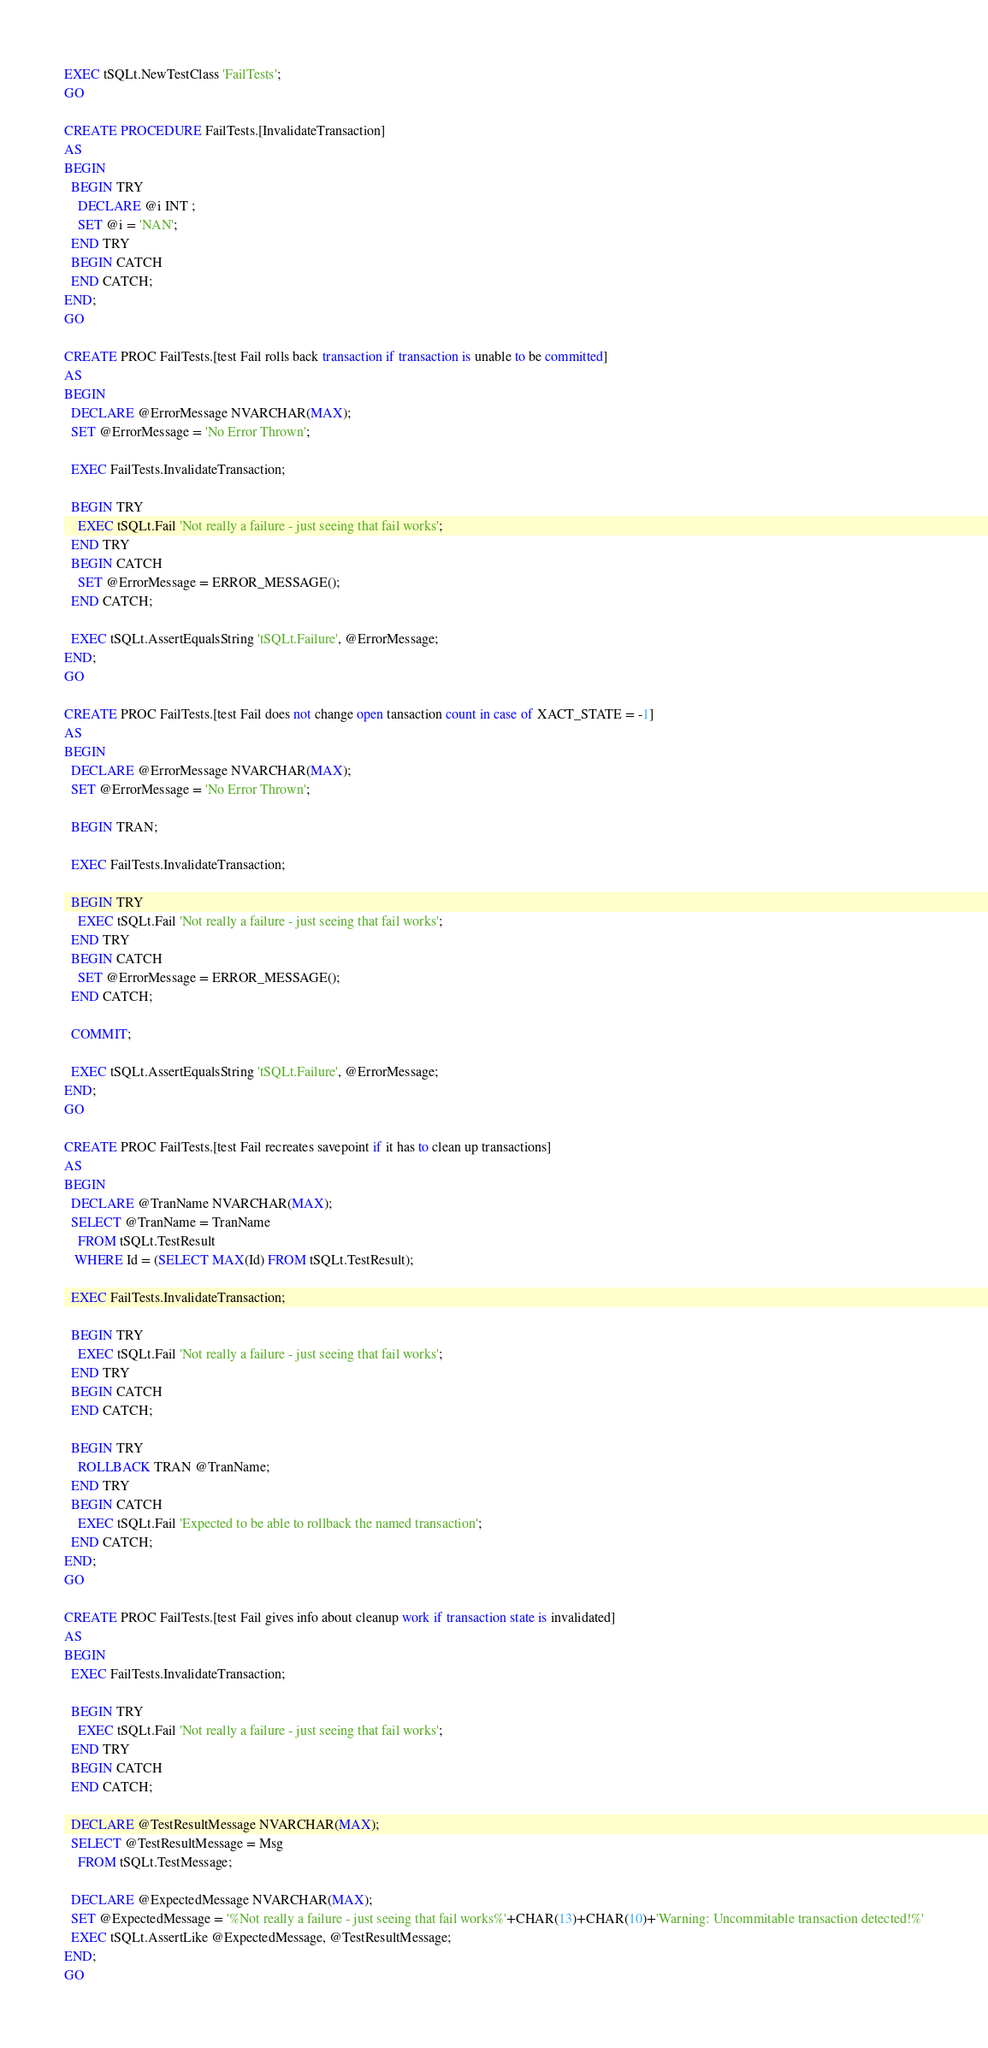<code> <loc_0><loc_0><loc_500><loc_500><_SQL_>EXEC tSQLt.NewTestClass 'FailTests';
GO

CREATE PROCEDURE FailTests.[InvalidateTransaction]
AS
BEGIN
  BEGIN TRY
    DECLARE @i INT ;
    SET @i = 'NAN';
  END TRY
  BEGIN CATCH
  END CATCH;
END;
GO

CREATE PROC FailTests.[test Fail rolls back transaction if transaction is unable to be committed]
AS
BEGIN
  DECLARE @ErrorMessage NVARCHAR(MAX);
  SET @ErrorMessage = 'No Error Thrown';

  EXEC FailTests.InvalidateTransaction;

  BEGIN TRY
    EXEC tSQLt.Fail 'Not really a failure - just seeing that fail works';
  END TRY
  BEGIN CATCH
    SET @ErrorMessage = ERROR_MESSAGE();
  END CATCH;

  EXEC tSQLt.AssertEqualsString 'tSQLt.Failure', @ErrorMessage;
END;
GO

CREATE PROC FailTests.[test Fail does not change open tansaction count in case of XACT_STATE = -1]
AS
BEGIN
  DECLARE @ErrorMessage NVARCHAR(MAX);
  SET @ErrorMessage = 'No Error Thrown';

  BEGIN TRAN;

  EXEC FailTests.InvalidateTransaction;

  BEGIN TRY
    EXEC tSQLt.Fail 'Not really a failure - just seeing that fail works';
  END TRY
  BEGIN CATCH
    SET @ErrorMessage = ERROR_MESSAGE();
  END CATCH;
  
  COMMIT;

  EXEC tSQLt.AssertEqualsString 'tSQLt.Failure', @ErrorMessage;
END;
GO

CREATE PROC FailTests.[test Fail recreates savepoint if it has to clean up transactions]
AS
BEGIN
  DECLARE @TranName NVARCHAR(MAX);
  SELECT @TranName = TranName
    FROM tSQLt.TestResult
   WHERE Id = (SELECT MAX(Id) FROM tSQLt.TestResult);

  EXEC FailTests.InvalidateTransaction;

  BEGIN TRY
    EXEC tSQLt.Fail 'Not really a failure - just seeing that fail works';
  END TRY
  BEGIN CATCH
  END CATCH;

  BEGIN TRY
    ROLLBACK TRAN @TranName;
  END TRY
  BEGIN CATCH
    EXEC tSQLt.Fail 'Expected to be able to rollback the named transaction';
  END CATCH;
END;
GO

CREATE PROC FailTests.[test Fail gives info about cleanup work if transaction state is invalidated]
AS
BEGIN
  EXEC FailTests.InvalidateTransaction;

  BEGIN TRY
    EXEC tSQLt.Fail 'Not really a failure - just seeing that fail works';
  END TRY
  BEGIN CATCH
  END CATCH;

  DECLARE @TestResultMessage NVARCHAR(MAX);
  SELECT @TestResultMessage = Msg
    FROM tSQLt.TestMessage;

  DECLARE @ExpectedMessage NVARCHAR(MAX);
  SET @ExpectedMessage = '%Not really a failure - just seeing that fail works%'+CHAR(13)+CHAR(10)+'Warning: Uncommitable transaction detected!%'
  EXEC tSQLt.AssertLike @ExpectedMessage, @TestResultMessage;
END;
GO</code> 